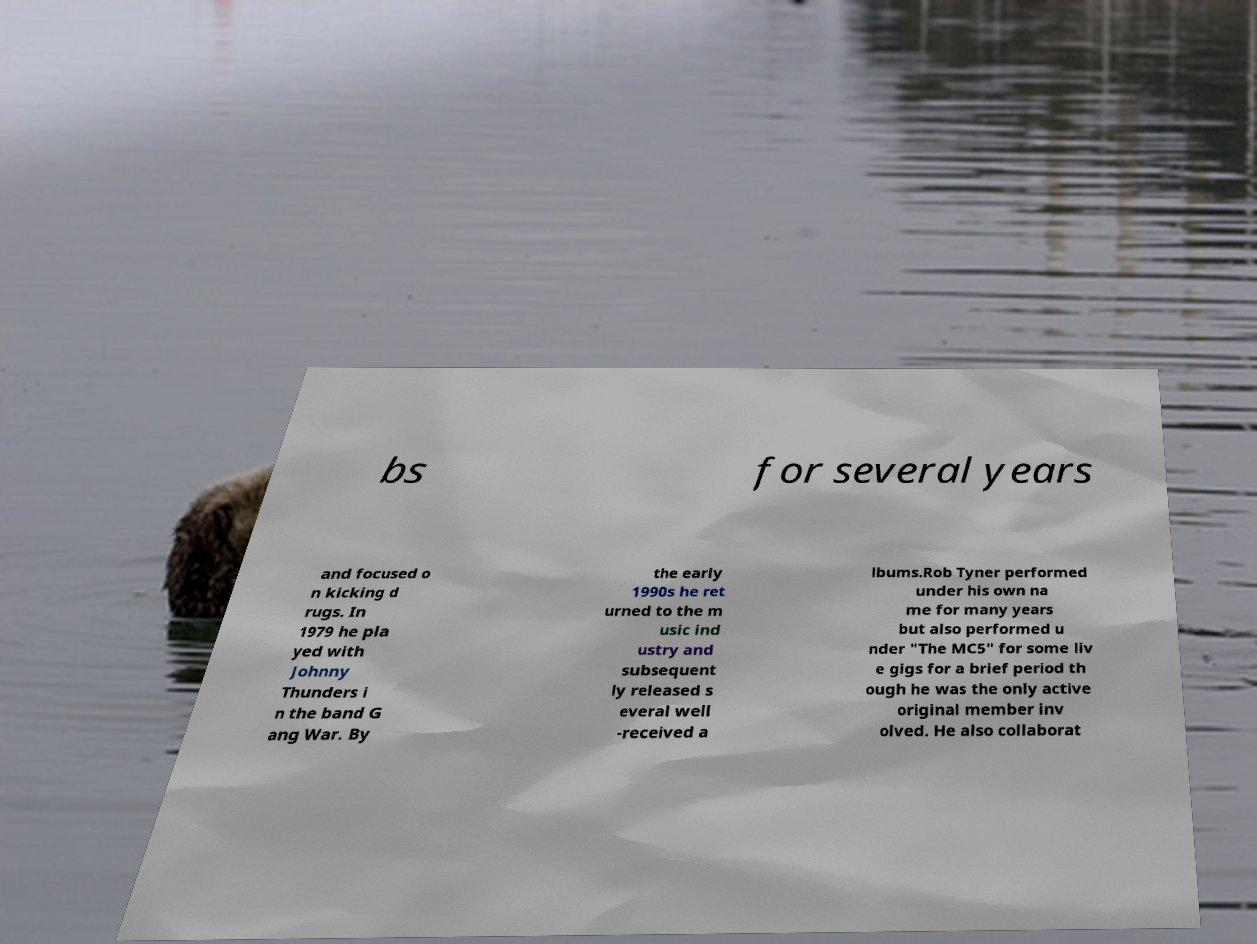Can you read and provide the text displayed in the image?This photo seems to have some interesting text. Can you extract and type it out for me? bs for several years and focused o n kicking d rugs. In 1979 he pla yed with Johnny Thunders i n the band G ang War. By the early 1990s he ret urned to the m usic ind ustry and subsequent ly released s everal well -received a lbums.Rob Tyner performed under his own na me for many years but also performed u nder "The MC5" for some liv e gigs for a brief period th ough he was the only active original member inv olved. He also collaborat 